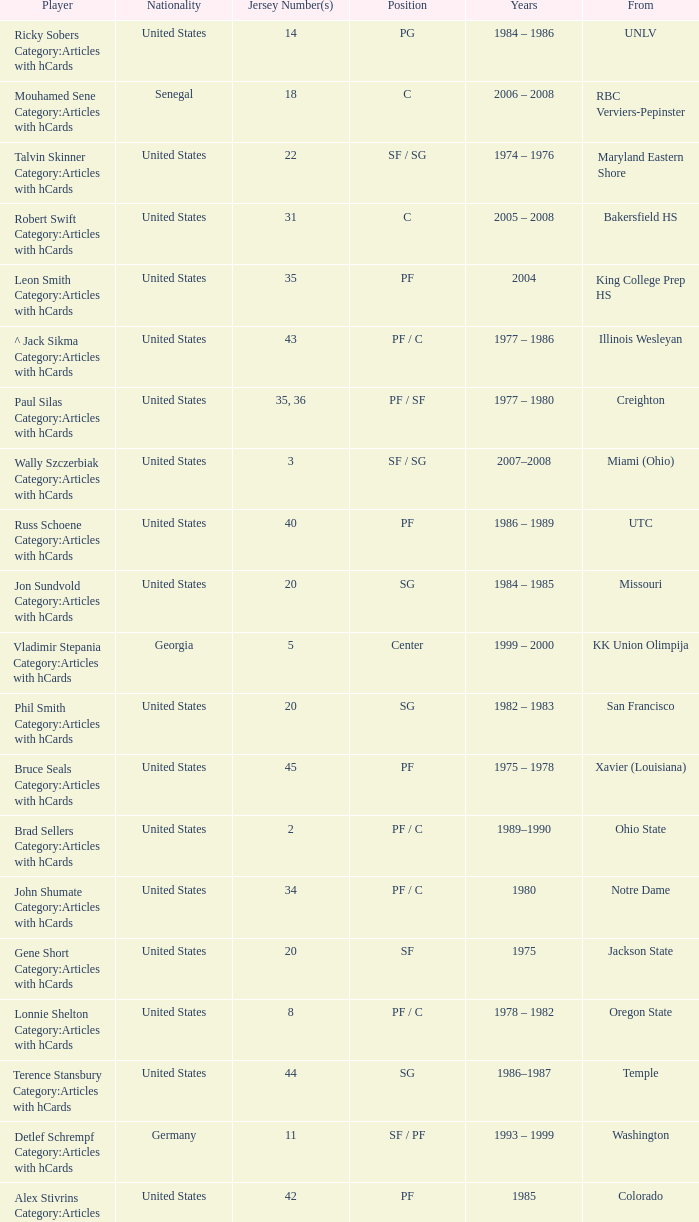What position does the player with jersey number 22 play? SF / SG. 